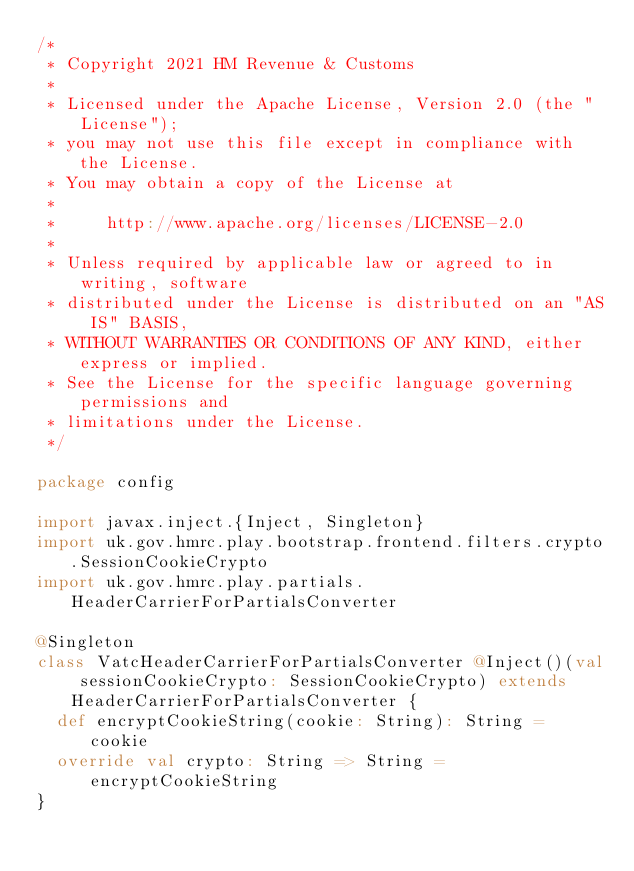Convert code to text. <code><loc_0><loc_0><loc_500><loc_500><_Scala_>/*
 * Copyright 2021 HM Revenue & Customs
 *
 * Licensed under the Apache License, Version 2.0 (the "License");
 * you may not use this file except in compliance with the License.
 * You may obtain a copy of the License at
 *
 *     http://www.apache.org/licenses/LICENSE-2.0
 *
 * Unless required by applicable law or agreed to in writing, software
 * distributed under the License is distributed on an "AS IS" BASIS,
 * WITHOUT WARRANTIES OR CONDITIONS OF ANY KIND, either express or implied.
 * See the License for the specific language governing permissions and
 * limitations under the License.
 */

package config

import javax.inject.{Inject, Singleton}
import uk.gov.hmrc.play.bootstrap.frontend.filters.crypto.SessionCookieCrypto
import uk.gov.hmrc.play.partials.HeaderCarrierForPartialsConverter

@Singleton
class VatcHeaderCarrierForPartialsConverter @Inject()(val sessionCookieCrypto: SessionCookieCrypto) extends HeaderCarrierForPartialsConverter {
  def encryptCookieString(cookie: String): String = cookie
  override val crypto: String => String = encryptCookieString
}</code> 